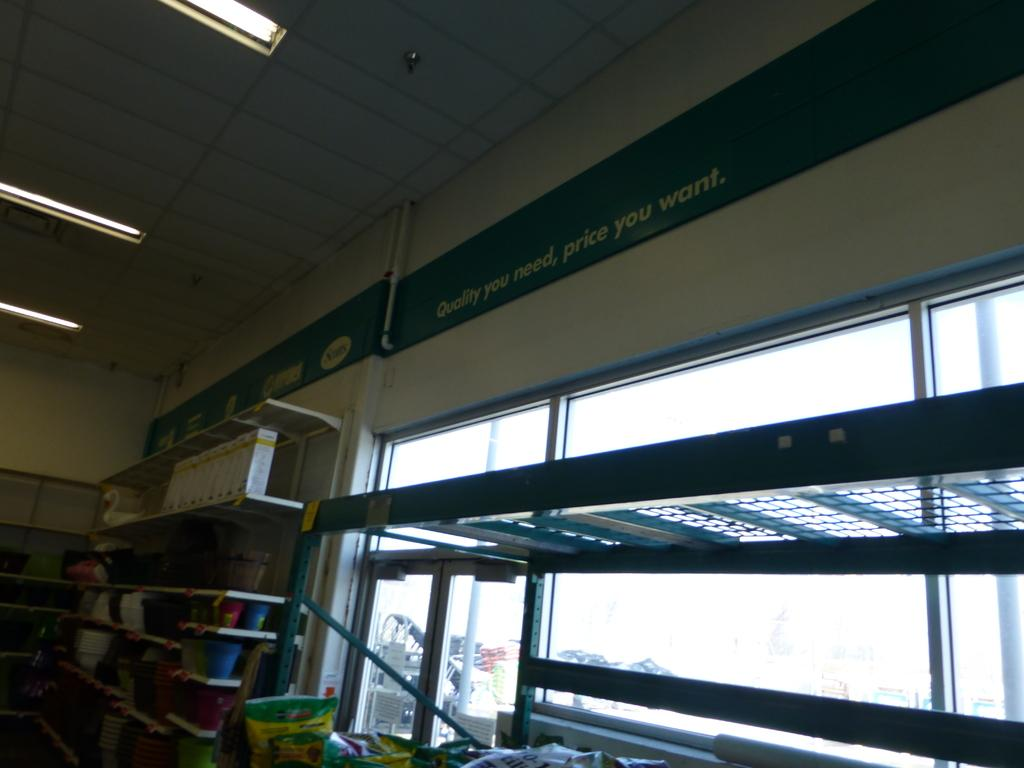Provide a one-sentence caption for the provided image. A sign is over the store shelves which states "quality you need, price you want but the shelves are almost bare. 